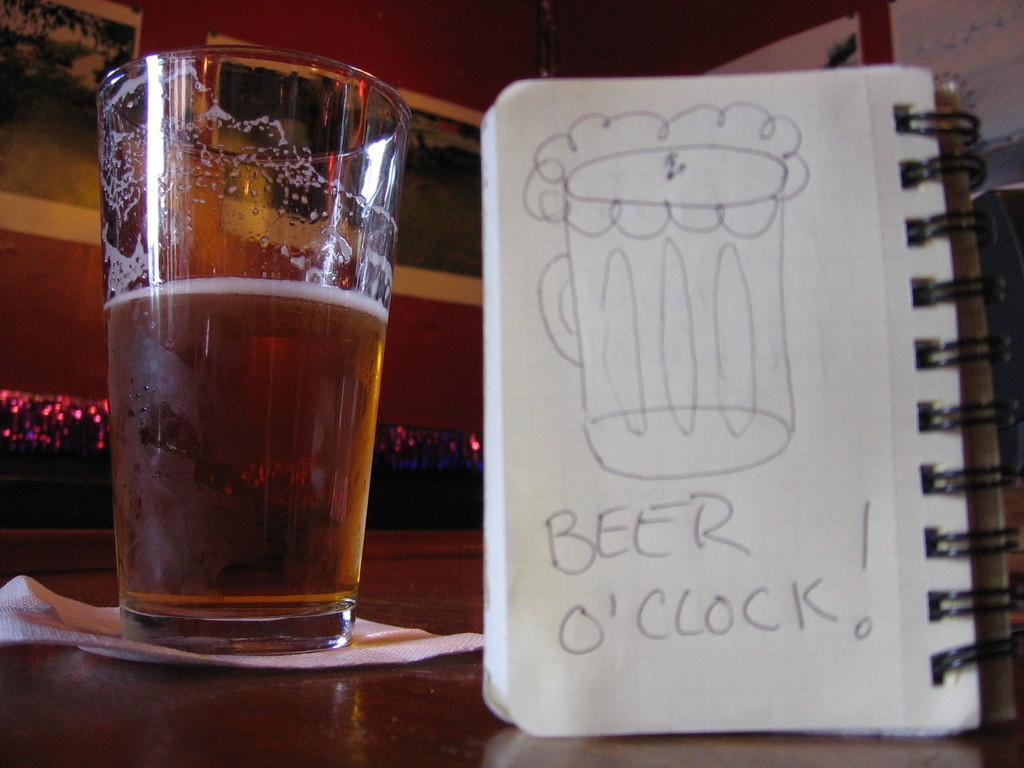<image>
Give a short and clear explanation of the subsequent image. a half drunk pint of beer sits on a counter with a pen drawing of said beer and the works "beer o'clock!" to the right of it 